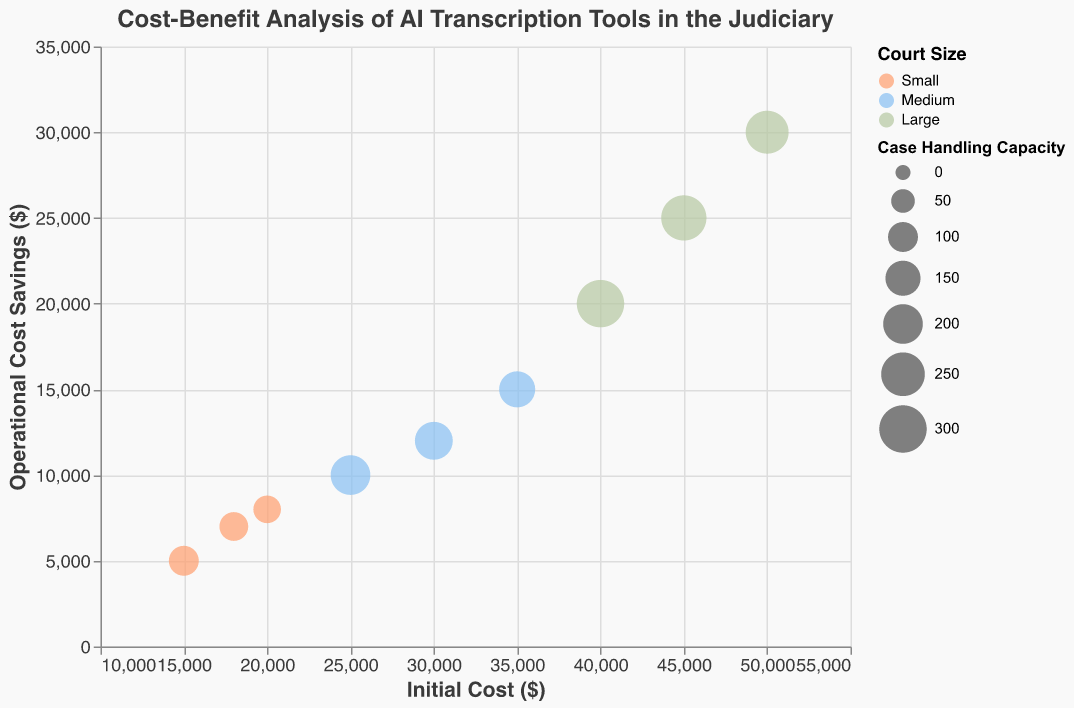What is the title of the figure? The title is displayed at the top of the chart. It reads "Cost-Benefit Analysis of AI Transcription Tools in the Judiciary".
Answer: Cost-Benefit Analysis of AI Transcription Tools in the Judiciary Which axis represents the initial cost of AI transcription tools? The x-axis title reads "Initial Cost ($)", which indicates that it represents the initial cost.
Answer: x-axis What court size has the highest operational cost savings for low complexity cases? Referring to the legend and the y-axis, the largest circle at the highest point on the y-axis for low complexity cases is for Large courts.
Answer: Large How many data points are depicted for each court size? The legend indicates three court sizes: Small, Medium, and Large. Counting the data points for each, Small has 3, Medium has 3, and Large has 3.
Answer: 3 What is the initial cost for Medium courts with high complexity cases? Locate the large triangle for Medium courts in the chart. The x-axis value for the large triangle representing high complexity cases is $35,000.
Answer: $35,000 Which court size and case complexity combination offers the highest case handling capacity? By examining the size of the circles, the largest circle represents Large courts with low complexity cases.
Answer: Large, Low Compare the operational cost savings between Small and Medium courts with high complexity cases. Locate the triangles for high complexity cases for Small and Medium courts. The y-axis values show Small courts save $8,000, and Medium courts save $15,000.
Answer: Medium courts save $7,000 more than Small courts What is the difference in initial cost between Large and Small courts for medium complexity cases? Locate the squares for medium complexity for both Large and Small courts. The x-axis value for Large is $45,000, and Small is $18,000. The difference is $27,000.
Answer: $27,000 Which combination shows the greatest accuracy improvement and what is its value? Using the tooltips or legend, identify the combination with the highest accuracy improvement. It is Large courts with high complexity cases, with an accuracy improvement of 30.
Answer: Large, High, 30 Identify the court size and case complexity with the lowest operational cost savings. The smallest value on the y-axis for operational cost savings is $5,000, which corresponds to Small courts with low complexity cases (circle).
Answer: Small, Low 